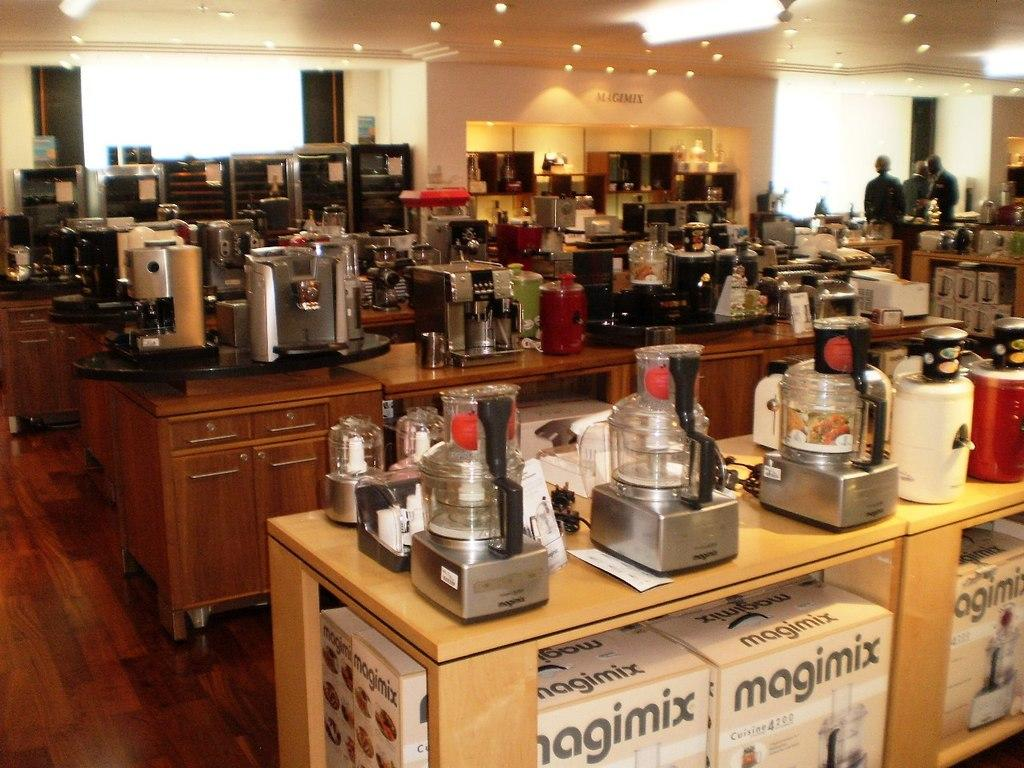<image>
Provide a brief description of the given image. A bunch of Magimix boxes are stored under display tables in a large store. 